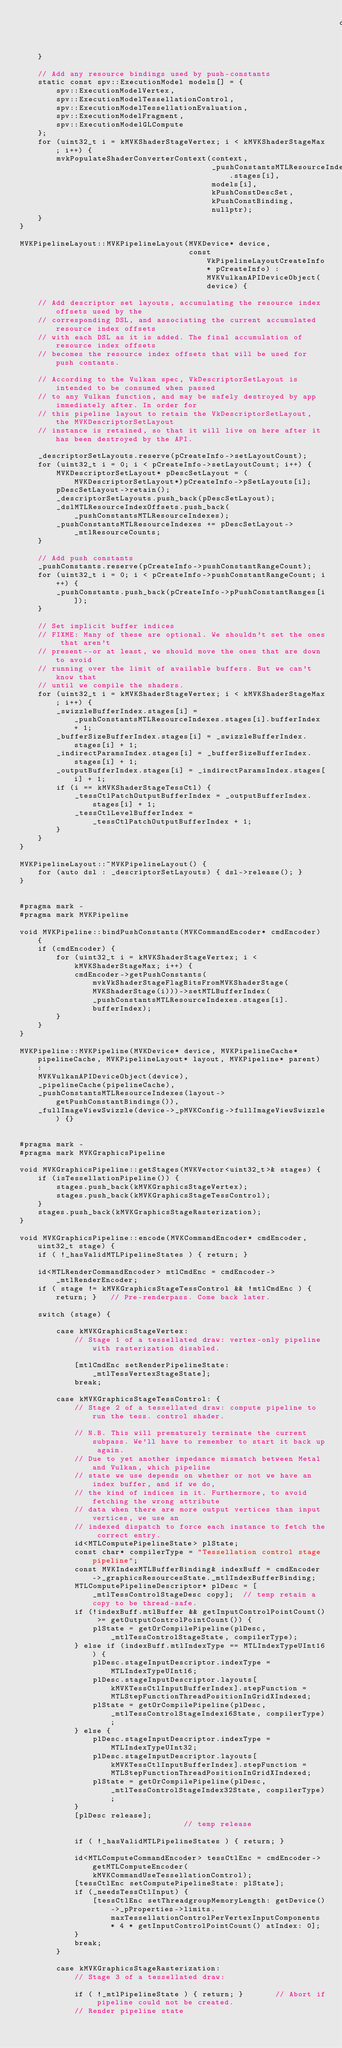Convert code to text. <code><loc_0><loc_0><loc_500><loc_500><_ObjectiveC_>																	  dslIdx);
	}

	// Add any resource bindings used by push-constants
	static const spv::ExecutionModel models[] = {
		spv::ExecutionModelVertex,
		spv::ExecutionModelTessellationControl,
		spv::ExecutionModelTessellationEvaluation,
		spv::ExecutionModelFragment,
		spv::ExecutionModelGLCompute
	};
	for (uint32_t i = kMVKShaderStageVertex; i < kMVKShaderStageMax; i++) {
		mvkPopulateShaderConverterContext(context,
										  _pushConstantsMTLResourceIndexes.stages[i],
										  models[i],
										  kPushConstDescSet,
										  kPushConstBinding,
										  nullptr);
	}
}

MVKPipelineLayout::MVKPipelineLayout(MVKDevice* device,
                                     const VkPipelineLayoutCreateInfo* pCreateInfo) : MVKVulkanAPIDeviceObject(device) {

    // Add descriptor set layouts, accumulating the resource index offsets used by the
    // corresponding DSL, and associating the current accumulated resource index offsets
    // with each DSL as it is added. The final accumulation of resource index offsets
    // becomes the resource index offsets that will be used for push contants.

    // According to the Vulkan spec, VkDescriptorSetLayout is intended to be consumed when passed
	// to any Vulkan function, and may be safely destroyed by app immediately after. In order for
	// this pipeline layout to retain the VkDescriptorSetLayout, the MVKDescriptorSetLayout
	// instance is retained, so that it will live on here after it has been destroyed by the API.

	_descriptorSetLayouts.reserve(pCreateInfo->setLayoutCount);
	for (uint32_t i = 0; i < pCreateInfo->setLayoutCount; i++) {
		MVKDescriptorSetLayout* pDescSetLayout = (MVKDescriptorSetLayout*)pCreateInfo->pSetLayouts[i];
		pDescSetLayout->retain();
		_descriptorSetLayouts.push_back(pDescSetLayout);
		_dslMTLResourceIndexOffsets.push_back(_pushConstantsMTLResourceIndexes);
		_pushConstantsMTLResourceIndexes += pDescSetLayout->_mtlResourceCounts;
	}

	// Add push constants
	_pushConstants.reserve(pCreateInfo->pushConstantRangeCount);
	for (uint32_t i = 0; i < pCreateInfo->pushConstantRangeCount; i++) {
		_pushConstants.push_back(pCreateInfo->pPushConstantRanges[i]);
	}

	// Set implicit buffer indices
	// FIXME: Many of these are optional. We shouldn't set the ones that aren't
	// present--or at least, we should move the ones that are down to avoid
	// running over the limit of available buffers. But we can't know that
	// until we compile the shaders.
	for (uint32_t i = kMVKShaderStageVertex; i < kMVKShaderStageMax; i++) {
		_swizzleBufferIndex.stages[i] = _pushConstantsMTLResourceIndexes.stages[i].bufferIndex + 1;
		_bufferSizeBufferIndex.stages[i] = _swizzleBufferIndex.stages[i] + 1;
		_indirectParamsIndex.stages[i] = _bufferSizeBufferIndex.stages[i] + 1;
		_outputBufferIndex.stages[i] = _indirectParamsIndex.stages[i] + 1;
		if (i == kMVKShaderStageTessCtl) {
			_tessCtlPatchOutputBufferIndex = _outputBufferIndex.stages[i] + 1;
			_tessCtlLevelBufferIndex = _tessCtlPatchOutputBufferIndex + 1;
		}
	}
}

MVKPipelineLayout::~MVKPipelineLayout() {
	for (auto dsl : _descriptorSetLayouts) { dsl->release(); }
}


#pragma mark -
#pragma mark MVKPipeline

void MVKPipeline::bindPushConstants(MVKCommandEncoder* cmdEncoder) {
	if (cmdEncoder) {
		for (uint32_t i = kMVKShaderStageVertex; i < kMVKShaderStageMax; i++) {
			cmdEncoder->getPushConstants(mvkVkShaderStageFlagBitsFromMVKShaderStage(MVKShaderStage(i)))->setMTLBufferIndex(_pushConstantsMTLResourceIndexes.stages[i].bufferIndex);
		}
	}
}

MVKPipeline::MVKPipeline(MVKDevice* device, MVKPipelineCache* pipelineCache, MVKPipelineLayout* layout, MVKPipeline* parent) :
	MVKVulkanAPIDeviceObject(device),
	_pipelineCache(pipelineCache),
	_pushConstantsMTLResourceIndexes(layout->getPushConstantBindings()),
	_fullImageViewSwizzle(device->_pMVKConfig->fullImageViewSwizzle) {}


#pragma mark -
#pragma mark MVKGraphicsPipeline

void MVKGraphicsPipeline::getStages(MVKVector<uint32_t>& stages) {
    if (isTessellationPipeline()) {
        stages.push_back(kMVKGraphicsStageVertex);
        stages.push_back(kMVKGraphicsStageTessControl);
    }
    stages.push_back(kMVKGraphicsStageRasterization);
}

void MVKGraphicsPipeline::encode(MVKCommandEncoder* cmdEncoder, uint32_t stage) {
	if ( !_hasValidMTLPipelineStates ) { return; }

    id<MTLRenderCommandEncoder> mtlCmdEnc = cmdEncoder->_mtlRenderEncoder;
    if ( stage != kMVKGraphicsStageTessControl && !mtlCmdEnc ) { return; }   // Pre-renderpass. Come back later.

    switch (stage) {

		case kMVKGraphicsStageVertex:
			// Stage 1 of a tessellated draw: vertex-only pipeline with rasterization disabled.

            [mtlCmdEnc setRenderPipelineState: _mtlTessVertexStageState];
            break;

        case kMVKGraphicsStageTessControl: {
			// Stage 2 of a tessellated draw: compute pipeline to run the tess. control shader.

			// N.B. This will prematurely terminate the current subpass. We'll have to remember to start it back up again.
			// Due to yet another impedance mismatch between Metal and Vulkan, which pipeline
			// state we use depends on whether or not we have an index buffer, and if we do,
			// the kind of indices in it. Furthermore, to avoid fetching the wrong attribute
			// data when there are more output vertices than input vertices, we use an
			// indexed dispatch to force each instance to fetch the correct entry.
            id<MTLComputePipelineState> plState;
			const char* compilerType = "Tessellation control stage pipeline";
			const MVKIndexMTLBufferBinding& indexBuff = cmdEncoder->_graphicsResourcesState._mtlIndexBufferBinding;
            MTLComputePipelineDescriptor* plDesc = [_mtlTessControlStageDesc copy];  // temp retain a copy to be thread-safe.
            if (!indexBuff.mtlBuffer && getInputControlPointCount() >= getOutputControlPointCount()) {
                plState = getOrCompilePipeline(plDesc, _mtlTessControlStageState, compilerType);
            } else if (indexBuff.mtlIndexType == MTLIndexTypeUInt16) {
                plDesc.stageInputDescriptor.indexType = MTLIndexTypeUInt16;
                plDesc.stageInputDescriptor.layouts[kMVKTessCtlInputBufferIndex].stepFunction = MTLStepFunctionThreadPositionInGridXIndexed;
                plState = getOrCompilePipeline(plDesc, _mtlTessControlStageIndex16State, compilerType);
            } else {
                plDesc.stageInputDescriptor.indexType = MTLIndexTypeUInt32;
                plDesc.stageInputDescriptor.layouts[kMVKTessCtlInputBufferIndex].stepFunction = MTLStepFunctionThreadPositionInGridXIndexed;
                plState = getOrCompilePipeline(plDesc, _mtlTessControlStageIndex32State, compilerType);
            }
			[plDesc release];														// temp release

			if ( !_hasValidMTLPipelineStates ) { return; }

            id<MTLComputeCommandEncoder> tessCtlEnc = cmdEncoder->getMTLComputeEncoder(kMVKCommandUseTessellationControl);
            [tessCtlEnc setComputePipelineState: plState];
            if (_needsTessCtlInput) {
                [tessCtlEnc setThreadgroupMemoryLength: getDevice()->_pProperties->limits.maxTessellationControlPerVertexInputComponents * 4 * getInputControlPointCount() atIndex: 0];
            }
            break;
        }

        case kMVKGraphicsStageRasterization:
			// Stage 3 of a tessellated draw:

			if ( !_mtlPipelineState ) { return; }		// Abort if pipeline could not be created.
            // Render pipeline state</code> 